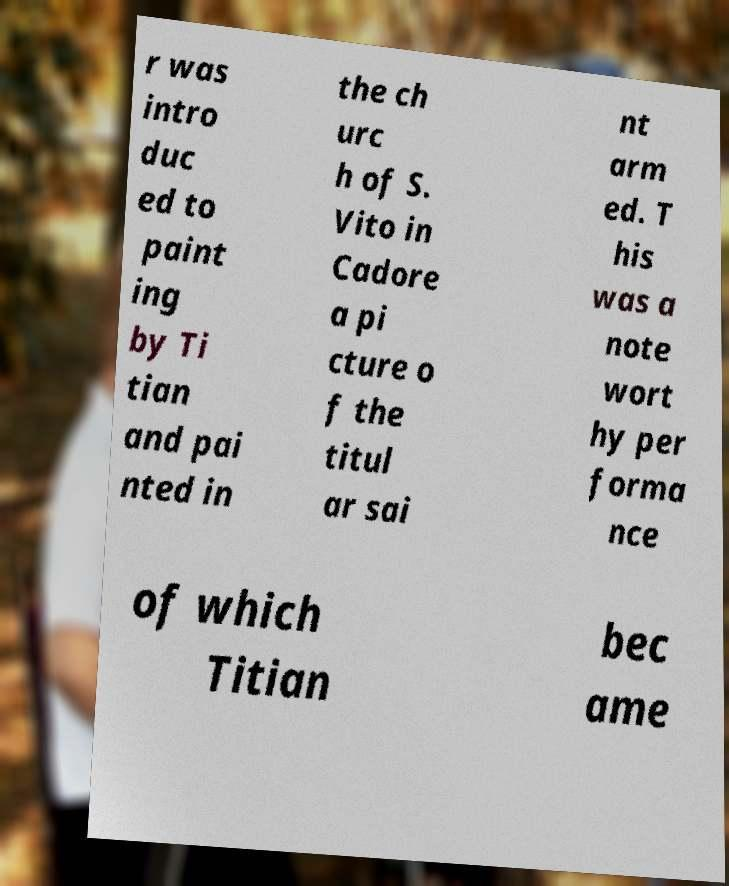I need the written content from this picture converted into text. Can you do that? r was intro duc ed to paint ing by Ti tian and pai nted in the ch urc h of S. Vito in Cadore a pi cture o f the titul ar sai nt arm ed. T his was a note wort hy per forma nce of which Titian bec ame 